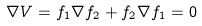<formula> <loc_0><loc_0><loc_500><loc_500>\nabla V = f _ { 1 } \nabla f _ { 2 } + f _ { 2 } \nabla f _ { 1 } = 0</formula> 